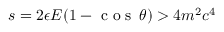<formula> <loc_0><loc_0><loc_500><loc_500>s = 2 \epsilon E ( 1 - \cos \, \theta ) > 4 m ^ { 2 } c ^ { 4 }</formula> 